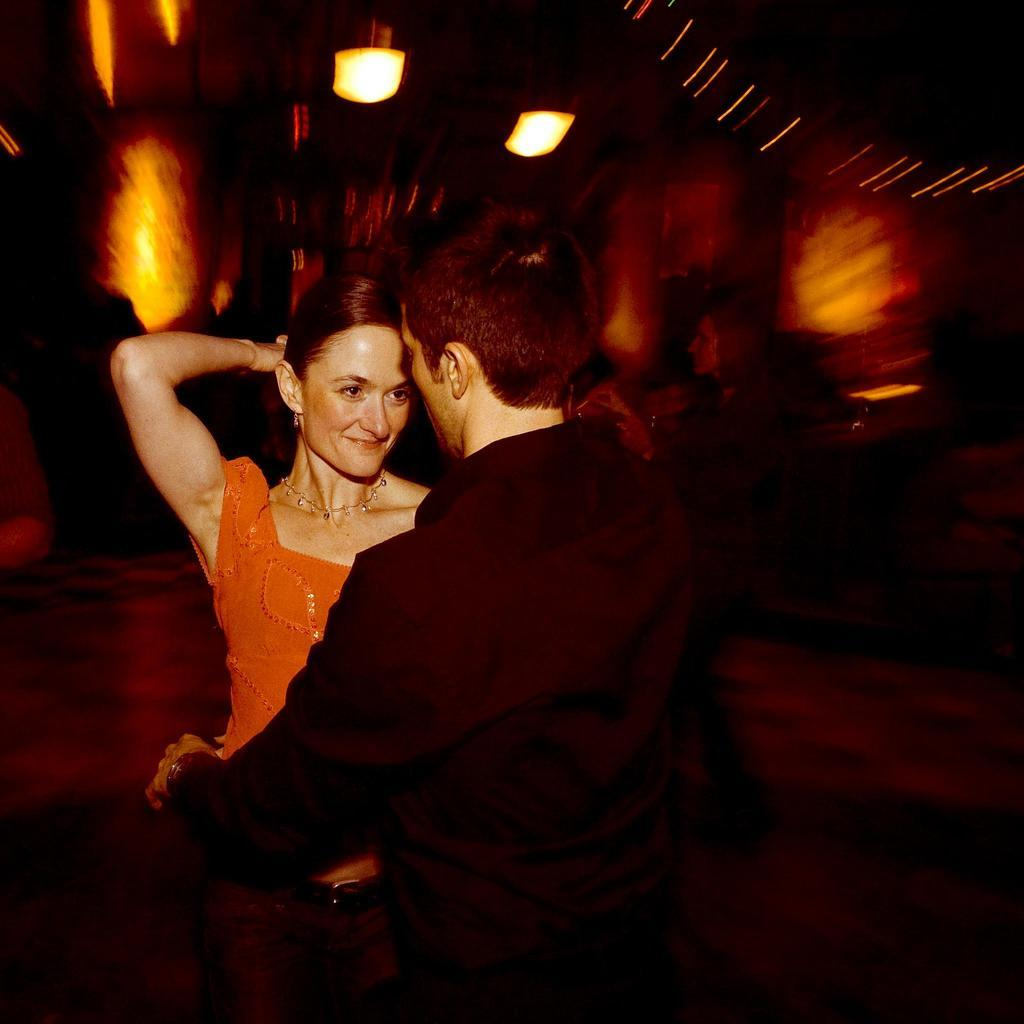How many people are in the image? There are two people in the center of the image. What can be observed about the background of the image? The background of the image is blurred. What time is displayed on the watch worn by the person in the image? There is no watch visible in the image. What type of medical treatment is being administered to the person in the image? There is no indication of a hospital or medical treatment in the image; it features two people in the center with a blurred background. 